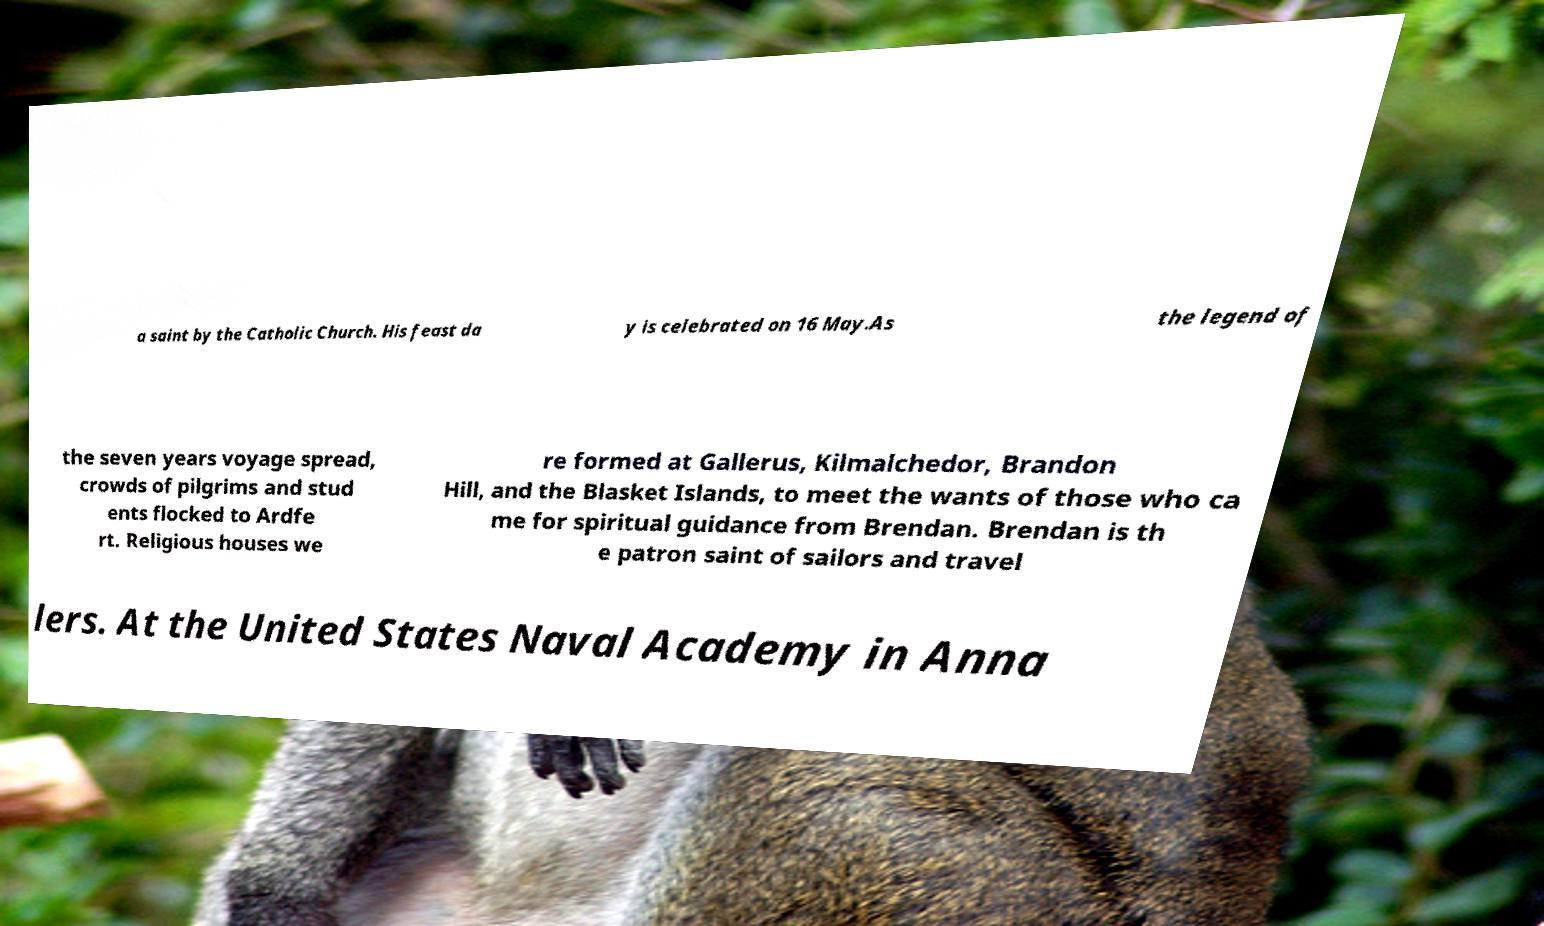Can you accurately transcribe the text from the provided image for me? a saint by the Catholic Church. His feast da y is celebrated on 16 May.As the legend of the seven years voyage spread, crowds of pilgrims and stud ents flocked to Ardfe rt. Religious houses we re formed at Gallerus, Kilmalchedor, Brandon Hill, and the Blasket Islands, to meet the wants of those who ca me for spiritual guidance from Brendan. Brendan is th e patron saint of sailors and travel lers. At the United States Naval Academy in Anna 